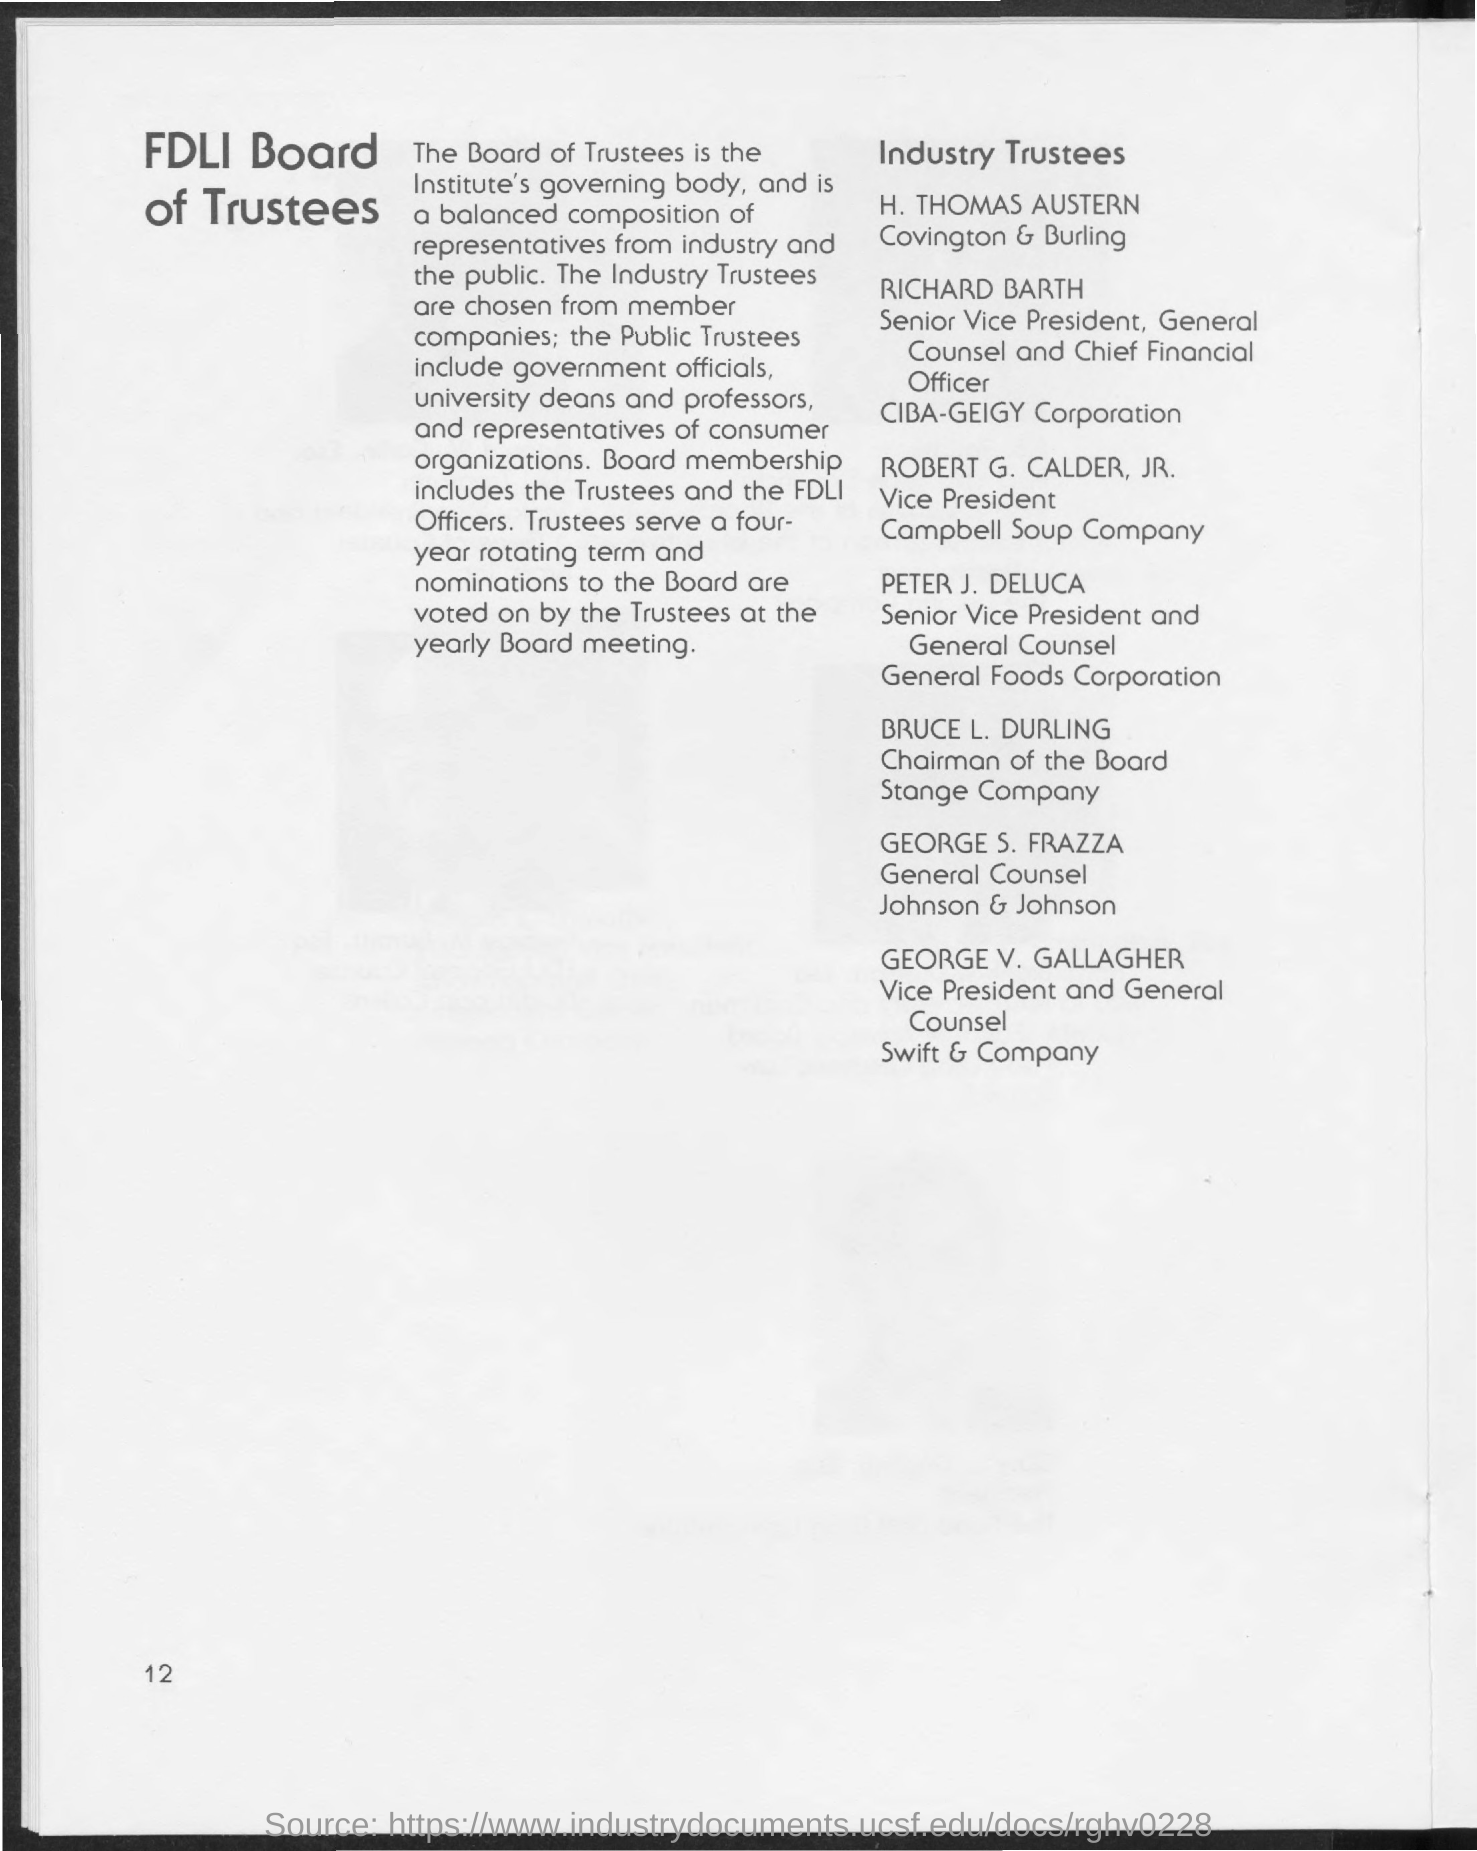Draw attention to some important aspects in this diagram. The Trustees for the industry are selected from among the member companies. The Board Membership includes the Trustees and the FDLI Officers. 